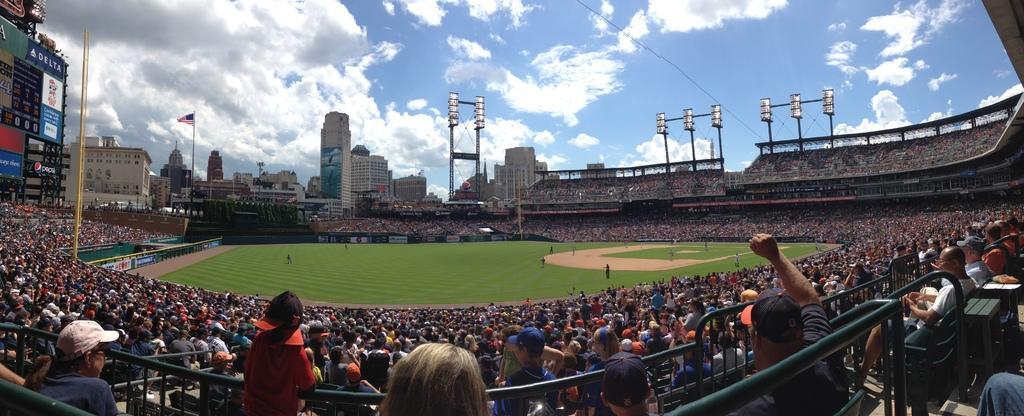Could you give a brief overview of what you see in this image? In this picture there is a stadium, where we can see grassland, people, boundaries, posters, poles, buildings and the sky. 